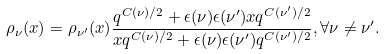Convert formula to latex. <formula><loc_0><loc_0><loc_500><loc_500>\rho _ { \nu } ( x ) = \rho _ { \nu ^ { \prime } } ( x ) \frac { q ^ { C ( \nu ) / 2 } + \epsilon ( \nu ) \epsilon ( \nu ^ { \prime } ) x q ^ { C ( \nu ^ { \prime } ) / 2 } } { x q ^ { C ( \nu ) / 2 } + \epsilon ( \nu ) \epsilon ( \nu ^ { \prime } ) q ^ { C ( \nu ^ { \prime } ) / 2 } } , \forall \nu \neq \nu ^ { \prime } .</formula> 